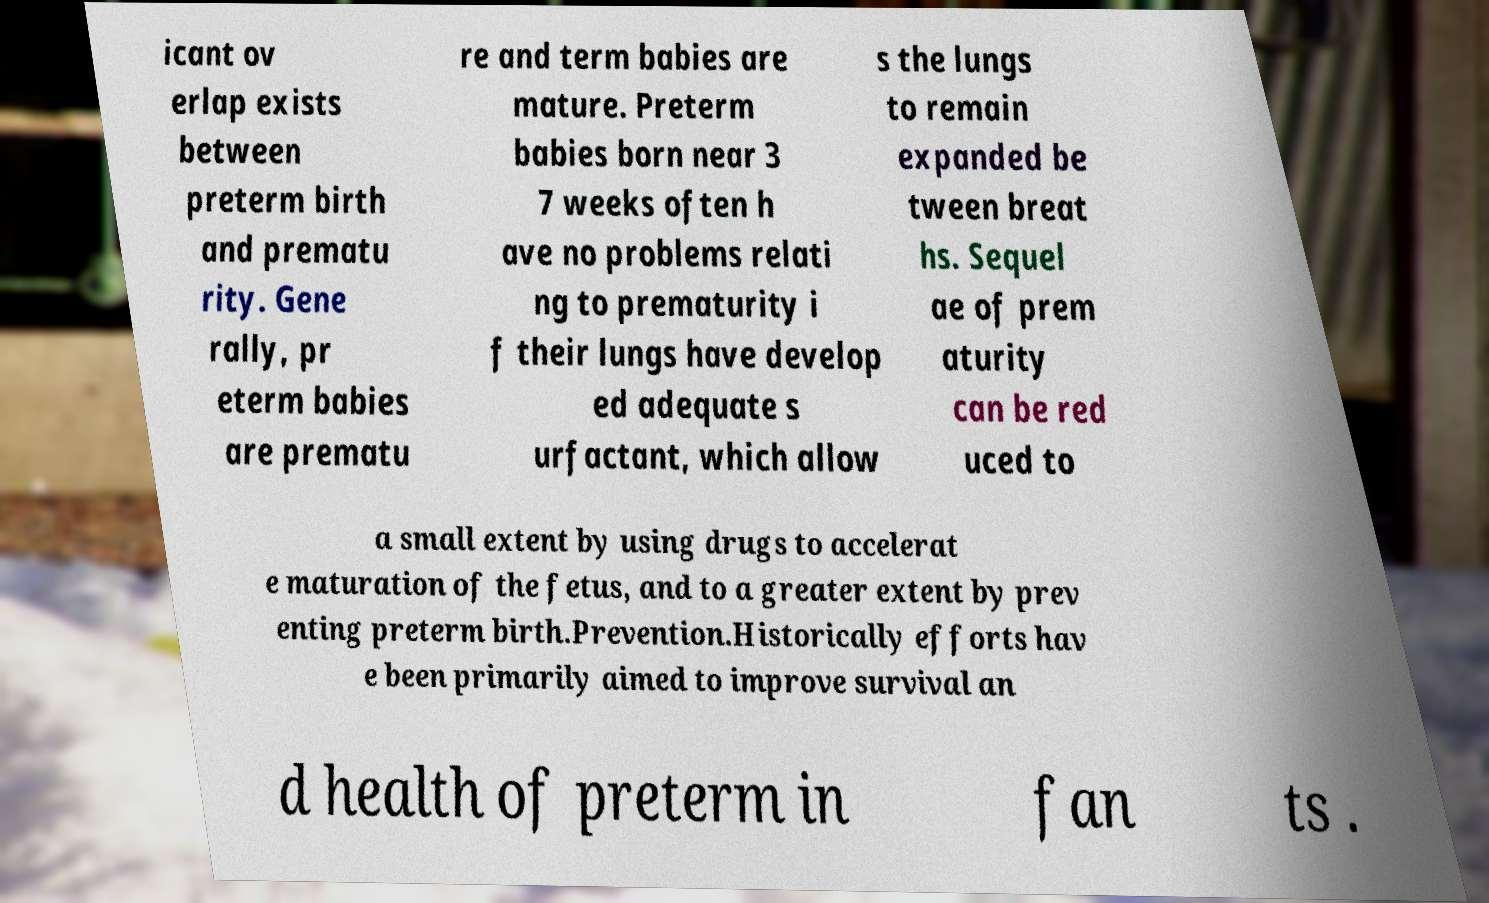Please read and relay the text visible in this image. What does it say? icant ov erlap exists between preterm birth and prematu rity. Gene rally, pr eterm babies are prematu re and term babies are mature. Preterm babies born near 3 7 weeks often h ave no problems relati ng to prematurity i f their lungs have develop ed adequate s urfactant, which allow s the lungs to remain expanded be tween breat hs. Sequel ae of prem aturity can be red uced to a small extent by using drugs to accelerat e maturation of the fetus, and to a greater extent by prev enting preterm birth.Prevention.Historically efforts hav e been primarily aimed to improve survival an d health of preterm in fan ts . 